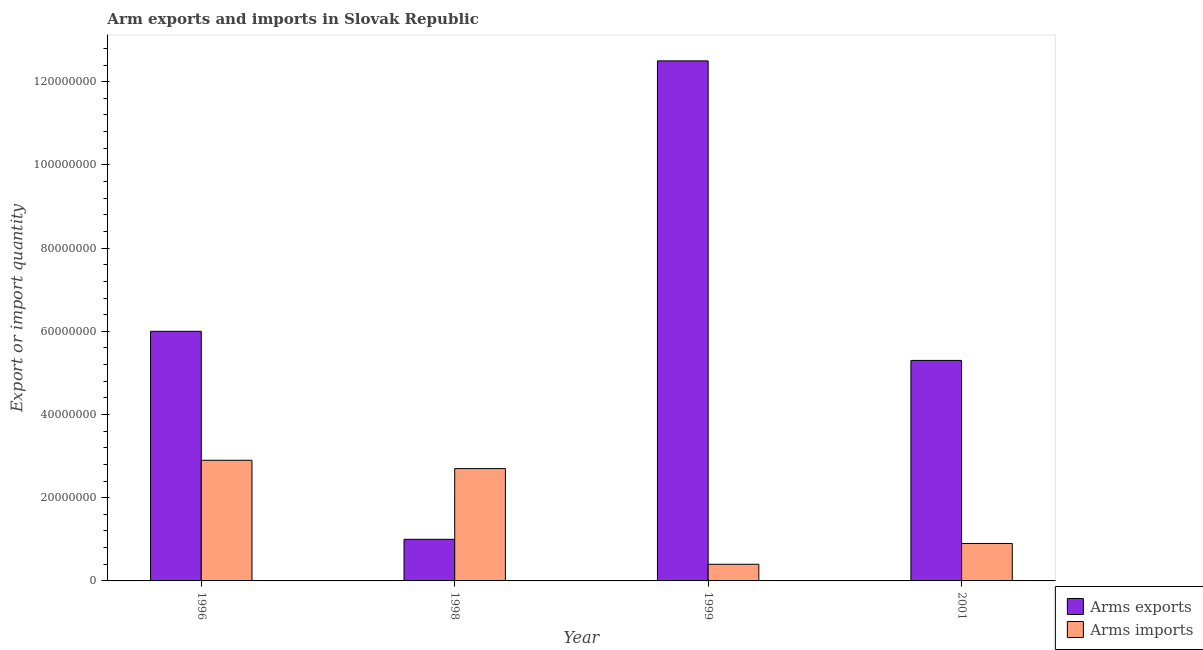How many different coloured bars are there?
Your answer should be compact. 2. How many groups of bars are there?
Offer a terse response. 4. Are the number of bars on each tick of the X-axis equal?
Offer a terse response. Yes. How many bars are there on the 4th tick from the right?
Your response must be concise. 2. What is the label of the 3rd group of bars from the left?
Provide a succinct answer. 1999. In how many cases, is the number of bars for a given year not equal to the number of legend labels?
Make the answer very short. 0. What is the arms imports in 1998?
Provide a short and direct response. 2.70e+07. Across all years, what is the maximum arms imports?
Make the answer very short. 2.90e+07. Across all years, what is the minimum arms exports?
Offer a terse response. 1.00e+07. What is the total arms imports in the graph?
Make the answer very short. 6.90e+07. What is the difference between the arms exports in 1996 and that in 2001?
Provide a succinct answer. 7.00e+06. What is the difference between the arms exports in 1996 and the arms imports in 1998?
Ensure brevity in your answer.  5.00e+07. What is the average arms imports per year?
Your response must be concise. 1.72e+07. Is the arms imports in 1996 less than that in 1998?
Make the answer very short. No. Is the difference between the arms imports in 1998 and 1999 greater than the difference between the arms exports in 1998 and 1999?
Offer a very short reply. No. What is the difference between the highest and the lowest arms exports?
Your answer should be very brief. 1.15e+08. What does the 1st bar from the left in 1998 represents?
Keep it short and to the point. Arms exports. What does the 1st bar from the right in 1999 represents?
Your answer should be compact. Arms imports. Are all the bars in the graph horizontal?
Ensure brevity in your answer.  No. How many years are there in the graph?
Give a very brief answer. 4. What is the difference between two consecutive major ticks on the Y-axis?
Your answer should be compact. 2.00e+07. Where does the legend appear in the graph?
Your answer should be very brief. Bottom right. How many legend labels are there?
Ensure brevity in your answer.  2. What is the title of the graph?
Your response must be concise. Arm exports and imports in Slovak Republic. Does "Technicians" appear as one of the legend labels in the graph?
Your answer should be compact. No. What is the label or title of the X-axis?
Offer a very short reply. Year. What is the label or title of the Y-axis?
Make the answer very short. Export or import quantity. What is the Export or import quantity in Arms exports in 1996?
Give a very brief answer. 6.00e+07. What is the Export or import quantity in Arms imports in 1996?
Make the answer very short. 2.90e+07. What is the Export or import quantity of Arms exports in 1998?
Give a very brief answer. 1.00e+07. What is the Export or import quantity in Arms imports in 1998?
Keep it short and to the point. 2.70e+07. What is the Export or import quantity of Arms exports in 1999?
Ensure brevity in your answer.  1.25e+08. What is the Export or import quantity in Arms imports in 1999?
Keep it short and to the point. 4.00e+06. What is the Export or import quantity of Arms exports in 2001?
Offer a terse response. 5.30e+07. What is the Export or import quantity in Arms imports in 2001?
Your answer should be very brief. 9.00e+06. Across all years, what is the maximum Export or import quantity in Arms exports?
Give a very brief answer. 1.25e+08. Across all years, what is the maximum Export or import quantity in Arms imports?
Offer a very short reply. 2.90e+07. Across all years, what is the minimum Export or import quantity of Arms imports?
Offer a very short reply. 4.00e+06. What is the total Export or import quantity of Arms exports in the graph?
Ensure brevity in your answer.  2.48e+08. What is the total Export or import quantity in Arms imports in the graph?
Offer a very short reply. 6.90e+07. What is the difference between the Export or import quantity in Arms imports in 1996 and that in 1998?
Offer a terse response. 2.00e+06. What is the difference between the Export or import quantity of Arms exports in 1996 and that in 1999?
Keep it short and to the point. -6.50e+07. What is the difference between the Export or import quantity of Arms imports in 1996 and that in 1999?
Ensure brevity in your answer.  2.50e+07. What is the difference between the Export or import quantity in Arms exports in 1996 and that in 2001?
Provide a succinct answer. 7.00e+06. What is the difference between the Export or import quantity in Arms imports in 1996 and that in 2001?
Provide a succinct answer. 2.00e+07. What is the difference between the Export or import quantity in Arms exports in 1998 and that in 1999?
Offer a very short reply. -1.15e+08. What is the difference between the Export or import quantity in Arms imports in 1998 and that in 1999?
Make the answer very short. 2.30e+07. What is the difference between the Export or import quantity in Arms exports in 1998 and that in 2001?
Make the answer very short. -4.30e+07. What is the difference between the Export or import quantity of Arms imports in 1998 and that in 2001?
Your answer should be very brief. 1.80e+07. What is the difference between the Export or import quantity of Arms exports in 1999 and that in 2001?
Keep it short and to the point. 7.20e+07. What is the difference between the Export or import quantity of Arms imports in 1999 and that in 2001?
Offer a terse response. -5.00e+06. What is the difference between the Export or import quantity in Arms exports in 1996 and the Export or import quantity in Arms imports in 1998?
Keep it short and to the point. 3.30e+07. What is the difference between the Export or import quantity of Arms exports in 1996 and the Export or import quantity of Arms imports in 1999?
Ensure brevity in your answer.  5.60e+07. What is the difference between the Export or import quantity in Arms exports in 1996 and the Export or import quantity in Arms imports in 2001?
Ensure brevity in your answer.  5.10e+07. What is the difference between the Export or import quantity in Arms exports in 1998 and the Export or import quantity in Arms imports in 2001?
Your response must be concise. 1.00e+06. What is the difference between the Export or import quantity of Arms exports in 1999 and the Export or import quantity of Arms imports in 2001?
Your answer should be compact. 1.16e+08. What is the average Export or import quantity of Arms exports per year?
Provide a short and direct response. 6.20e+07. What is the average Export or import quantity of Arms imports per year?
Your response must be concise. 1.72e+07. In the year 1996, what is the difference between the Export or import quantity of Arms exports and Export or import quantity of Arms imports?
Provide a short and direct response. 3.10e+07. In the year 1998, what is the difference between the Export or import quantity of Arms exports and Export or import quantity of Arms imports?
Give a very brief answer. -1.70e+07. In the year 1999, what is the difference between the Export or import quantity in Arms exports and Export or import quantity in Arms imports?
Provide a succinct answer. 1.21e+08. In the year 2001, what is the difference between the Export or import quantity of Arms exports and Export or import quantity of Arms imports?
Your answer should be very brief. 4.40e+07. What is the ratio of the Export or import quantity of Arms imports in 1996 to that in 1998?
Your response must be concise. 1.07. What is the ratio of the Export or import quantity in Arms exports in 1996 to that in 1999?
Your answer should be very brief. 0.48. What is the ratio of the Export or import quantity in Arms imports in 1996 to that in 1999?
Your answer should be compact. 7.25. What is the ratio of the Export or import quantity of Arms exports in 1996 to that in 2001?
Your response must be concise. 1.13. What is the ratio of the Export or import quantity of Arms imports in 1996 to that in 2001?
Your answer should be very brief. 3.22. What is the ratio of the Export or import quantity of Arms exports in 1998 to that in 1999?
Your answer should be very brief. 0.08. What is the ratio of the Export or import quantity in Arms imports in 1998 to that in 1999?
Make the answer very short. 6.75. What is the ratio of the Export or import quantity of Arms exports in 1998 to that in 2001?
Provide a succinct answer. 0.19. What is the ratio of the Export or import quantity of Arms exports in 1999 to that in 2001?
Your response must be concise. 2.36. What is the ratio of the Export or import quantity in Arms imports in 1999 to that in 2001?
Offer a terse response. 0.44. What is the difference between the highest and the second highest Export or import quantity of Arms exports?
Give a very brief answer. 6.50e+07. What is the difference between the highest and the lowest Export or import quantity of Arms exports?
Offer a terse response. 1.15e+08. What is the difference between the highest and the lowest Export or import quantity in Arms imports?
Ensure brevity in your answer.  2.50e+07. 